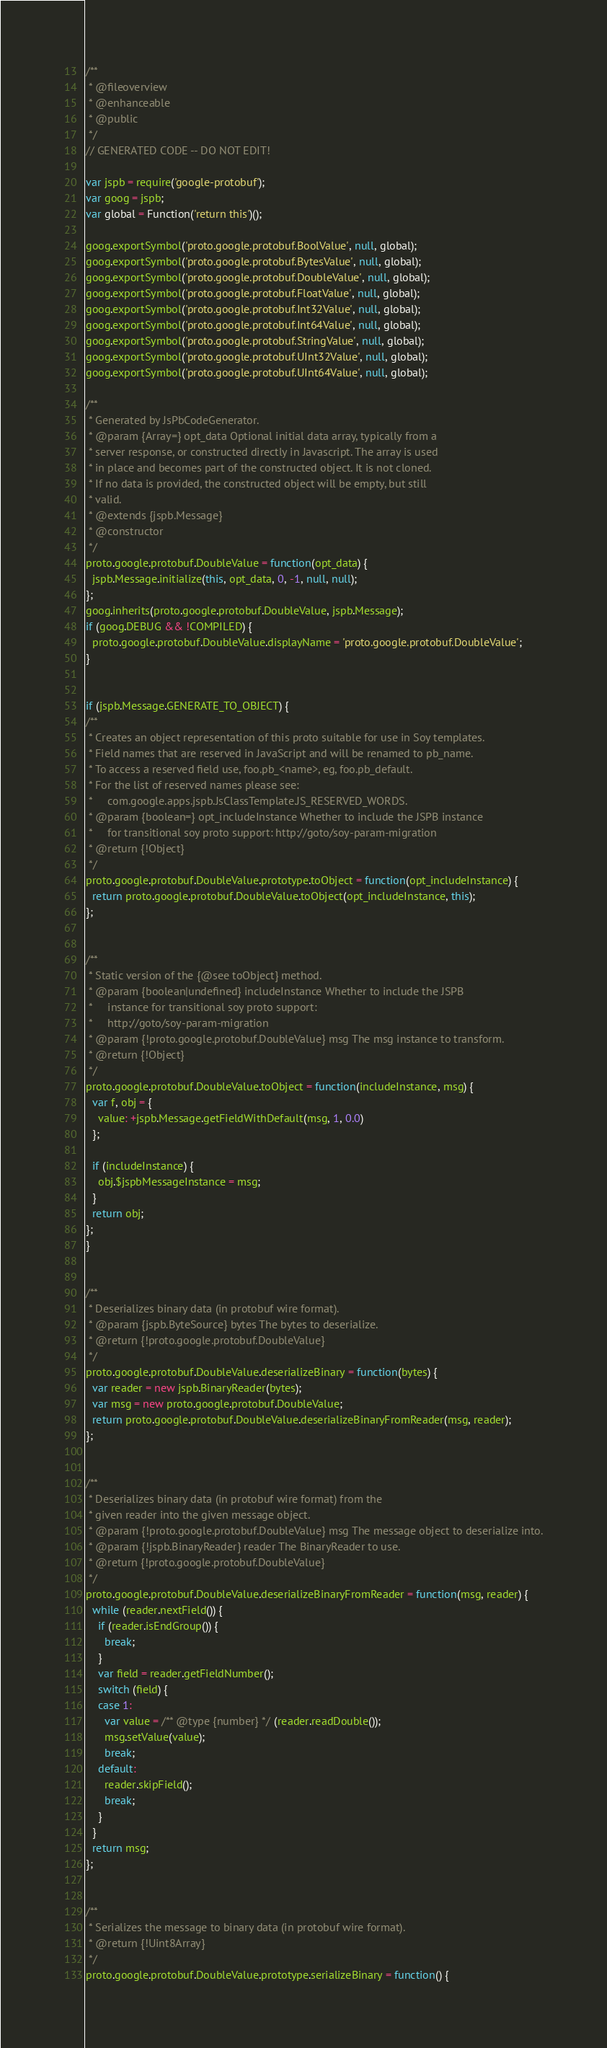<code> <loc_0><loc_0><loc_500><loc_500><_JavaScript_>/**
 * @fileoverview
 * @enhanceable
 * @public
 */
// GENERATED CODE -- DO NOT EDIT!

var jspb = require('google-protobuf');
var goog = jspb;
var global = Function('return this')();

goog.exportSymbol('proto.google.protobuf.BoolValue', null, global);
goog.exportSymbol('proto.google.protobuf.BytesValue', null, global);
goog.exportSymbol('proto.google.protobuf.DoubleValue', null, global);
goog.exportSymbol('proto.google.protobuf.FloatValue', null, global);
goog.exportSymbol('proto.google.protobuf.Int32Value', null, global);
goog.exportSymbol('proto.google.protobuf.Int64Value', null, global);
goog.exportSymbol('proto.google.protobuf.StringValue', null, global);
goog.exportSymbol('proto.google.protobuf.UInt32Value', null, global);
goog.exportSymbol('proto.google.protobuf.UInt64Value', null, global);

/**
 * Generated by JsPbCodeGenerator.
 * @param {Array=} opt_data Optional initial data array, typically from a
 * server response, or constructed directly in Javascript. The array is used
 * in place and becomes part of the constructed object. It is not cloned.
 * If no data is provided, the constructed object will be empty, but still
 * valid.
 * @extends {jspb.Message}
 * @constructor
 */
proto.google.protobuf.DoubleValue = function(opt_data) {
  jspb.Message.initialize(this, opt_data, 0, -1, null, null);
};
goog.inherits(proto.google.protobuf.DoubleValue, jspb.Message);
if (goog.DEBUG && !COMPILED) {
  proto.google.protobuf.DoubleValue.displayName = 'proto.google.protobuf.DoubleValue';
}


if (jspb.Message.GENERATE_TO_OBJECT) {
/**
 * Creates an object representation of this proto suitable for use in Soy templates.
 * Field names that are reserved in JavaScript and will be renamed to pb_name.
 * To access a reserved field use, foo.pb_<name>, eg, foo.pb_default.
 * For the list of reserved names please see:
 *     com.google.apps.jspb.JsClassTemplate.JS_RESERVED_WORDS.
 * @param {boolean=} opt_includeInstance Whether to include the JSPB instance
 *     for transitional soy proto support: http://goto/soy-param-migration
 * @return {!Object}
 */
proto.google.protobuf.DoubleValue.prototype.toObject = function(opt_includeInstance) {
  return proto.google.protobuf.DoubleValue.toObject(opt_includeInstance, this);
};


/**
 * Static version of the {@see toObject} method.
 * @param {boolean|undefined} includeInstance Whether to include the JSPB
 *     instance for transitional soy proto support:
 *     http://goto/soy-param-migration
 * @param {!proto.google.protobuf.DoubleValue} msg The msg instance to transform.
 * @return {!Object}
 */
proto.google.protobuf.DoubleValue.toObject = function(includeInstance, msg) {
  var f, obj = {
    value: +jspb.Message.getFieldWithDefault(msg, 1, 0.0)
  };

  if (includeInstance) {
    obj.$jspbMessageInstance = msg;
  }
  return obj;
};
}


/**
 * Deserializes binary data (in protobuf wire format).
 * @param {jspb.ByteSource} bytes The bytes to deserialize.
 * @return {!proto.google.protobuf.DoubleValue}
 */
proto.google.protobuf.DoubleValue.deserializeBinary = function(bytes) {
  var reader = new jspb.BinaryReader(bytes);
  var msg = new proto.google.protobuf.DoubleValue;
  return proto.google.protobuf.DoubleValue.deserializeBinaryFromReader(msg, reader);
};


/**
 * Deserializes binary data (in protobuf wire format) from the
 * given reader into the given message object.
 * @param {!proto.google.protobuf.DoubleValue} msg The message object to deserialize into.
 * @param {!jspb.BinaryReader} reader The BinaryReader to use.
 * @return {!proto.google.protobuf.DoubleValue}
 */
proto.google.protobuf.DoubleValue.deserializeBinaryFromReader = function(msg, reader) {
  while (reader.nextField()) {
    if (reader.isEndGroup()) {
      break;
    }
    var field = reader.getFieldNumber();
    switch (field) {
    case 1:
      var value = /** @type {number} */ (reader.readDouble());
      msg.setValue(value);
      break;
    default:
      reader.skipField();
      break;
    }
  }
  return msg;
};


/**
 * Serializes the message to binary data (in protobuf wire format).
 * @return {!Uint8Array}
 */
proto.google.protobuf.DoubleValue.prototype.serializeBinary = function() {</code> 